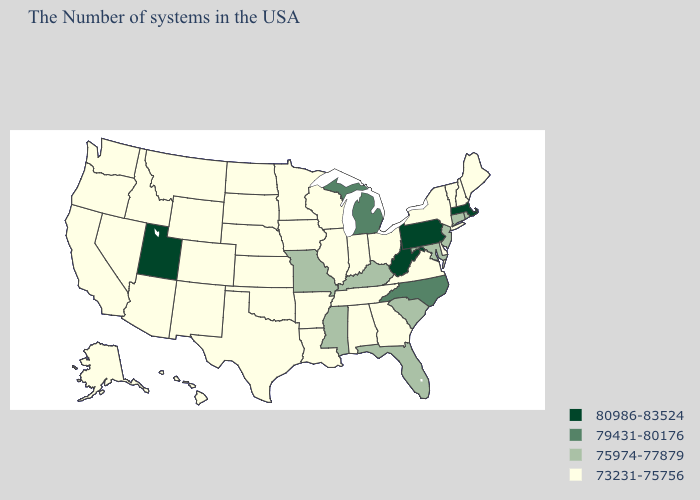What is the value of Ohio?
Quick response, please. 73231-75756. Name the states that have a value in the range 73231-75756?
Answer briefly. Maine, New Hampshire, Vermont, New York, Delaware, Virginia, Ohio, Georgia, Indiana, Alabama, Tennessee, Wisconsin, Illinois, Louisiana, Arkansas, Minnesota, Iowa, Kansas, Nebraska, Oklahoma, Texas, South Dakota, North Dakota, Wyoming, Colorado, New Mexico, Montana, Arizona, Idaho, Nevada, California, Washington, Oregon, Alaska, Hawaii. What is the value of Nebraska?
Give a very brief answer. 73231-75756. Name the states that have a value in the range 79431-80176?
Short answer required. North Carolina, Michigan. Does Utah have the highest value in the West?
Give a very brief answer. Yes. Name the states that have a value in the range 79431-80176?
Be succinct. North Carolina, Michigan. What is the lowest value in the West?
Give a very brief answer. 73231-75756. Does Nebraska have the lowest value in the USA?
Give a very brief answer. Yes. What is the lowest value in the South?
Write a very short answer. 73231-75756. Name the states that have a value in the range 73231-75756?
Give a very brief answer. Maine, New Hampshire, Vermont, New York, Delaware, Virginia, Ohio, Georgia, Indiana, Alabama, Tennessee, Wisconsin, Illinois, Louisiana, Arkansas, Minnesota, Iowa, Kansas, Nebraska, Oklahoma, Texas, South Dakota, North Dakota, Wyoming, Colorado, New Mexico, Montana, Arizona, Idaho, Nevada, California, Washington, Oregon, Alaska, Hawaii. What is the highest value in states that border Wyoming?
Quick response, please. 80986-83524. What is the highest value in the USA?
Keep it brief. 80986-83524. What is the lowest value in the USA?
Give a very brief answer. 73231-75756. Does West Virginia have the highest value in the USA?
Keep it brief. Yes. Which states hav the highest value in the Northeast?
Quick response, please. Massachusetts, Pennsylvania. 